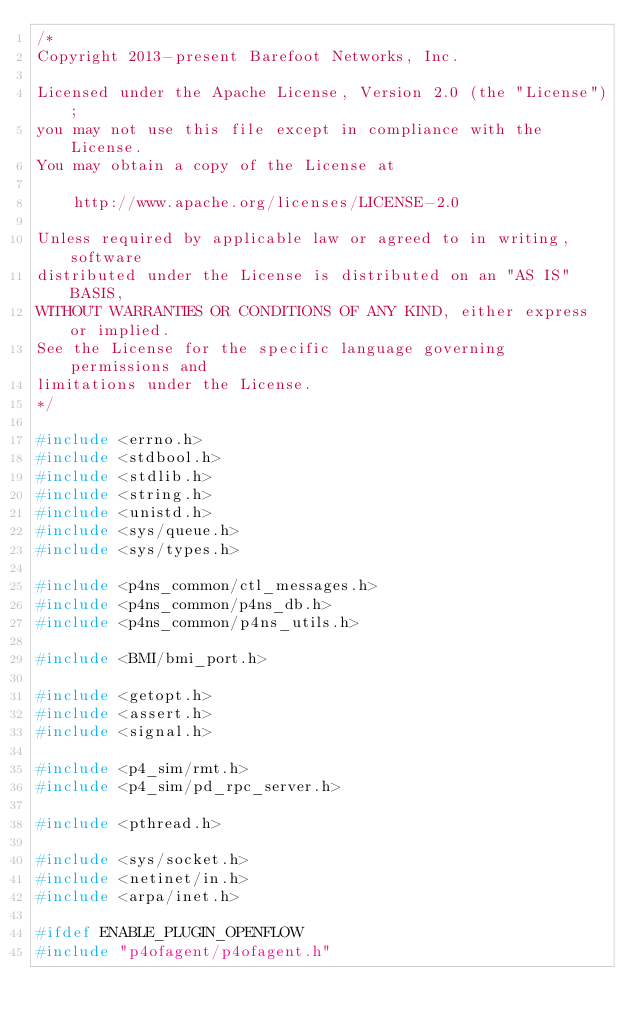Convert code to text. <code><loc_0><loc_0><loc_500><loc_500><_C_>/*
Copyright 2013-present Barefoot Networks, Inc.

Licensed under the Apache License, Version 2.0 (the "License");
you may not use this file except in compliance with the License.
You may obtain a copy of the License at

    http://www.apache.org/licenses/LICENSE-2.0

Unless required by applicable law or agreed to in writing, software
distributed under the License is distributed on an "AS IS" BASIS,
WITHOUT WARRANTIES OR CONDITIONS OF ANY KIND, either express or implied.
See the License for the specific language governing permissions and
limitations under the License.
*/

#include <errno.h>
#include <stdbool.h>
#include <stdlib.h>
#include <string.h>
#include <unistd.h>
#include <sys/queue.h>
#include <sys/types.h>

#include <p4ns_common/ctl_messages.h>
#include <p4ns_common/p4ns_db.h>
#include <p4ns_common/p4ns_utils.h>

#include <BMI/bmi_port.h>

#include <getopt.h>
#include <assert.h>
#include <signal.h>

#include <p4_sim/rmt.h>
#include <p4_sim/pd_rpc_server.h>

#include <pthread.h>

#include <sys/socket.h>
#include <netinet/in.h>
#include <arpa/inet.h>

#ifdef ENABLE_PLUGIN_OPENFLOW
#include "p4ofagent/p4ofagent.h"</code> 